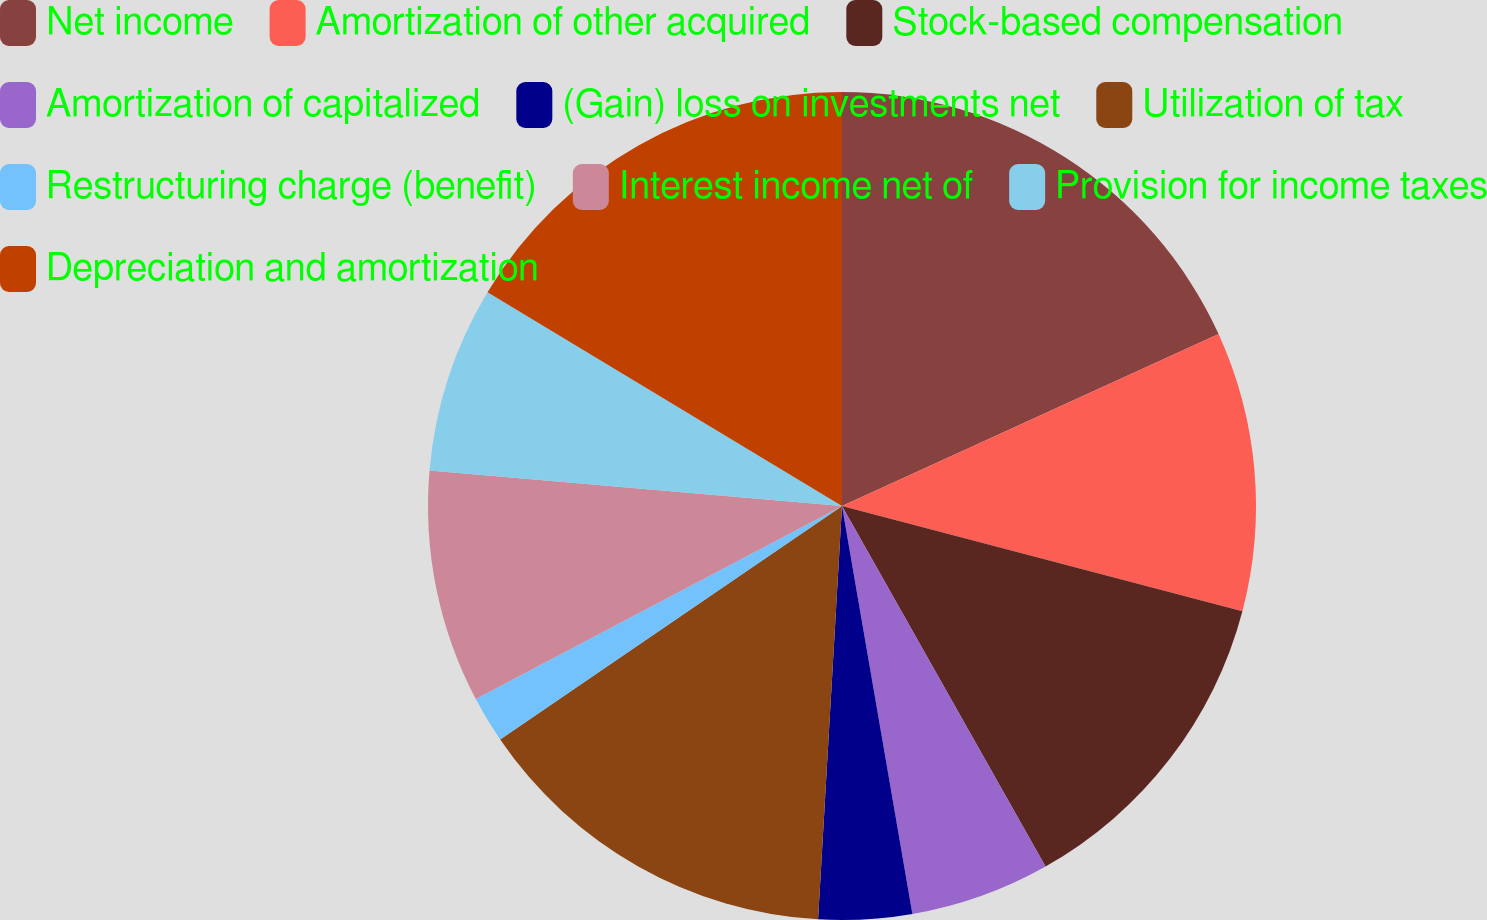Convert chart to OTSL. <chart><loc_0><loc_0><loc_500><loc_500><pie_chart><fcel>Net income<fcel>Amortization of other acquired<fcel>Stock-based compensation<fcel>Amortization of capitalized<fcel>(Gain) loss on investments net<fcel>Utilization of tax<fcel>Restructuring charge (benefit)<fcel>Interest income net of<fcel>Provision for income taxes<fcel>Depreciation and amortization<nl><fcel>18.18%<fcel>10.91%<fcel>12.73%<fcel>5.46%<fcel>3.64%<fcel>14.54%<fcel>1.82%<fcel>9.09%<fcel>7.27%<fcel>16.36%<nl></chart> 